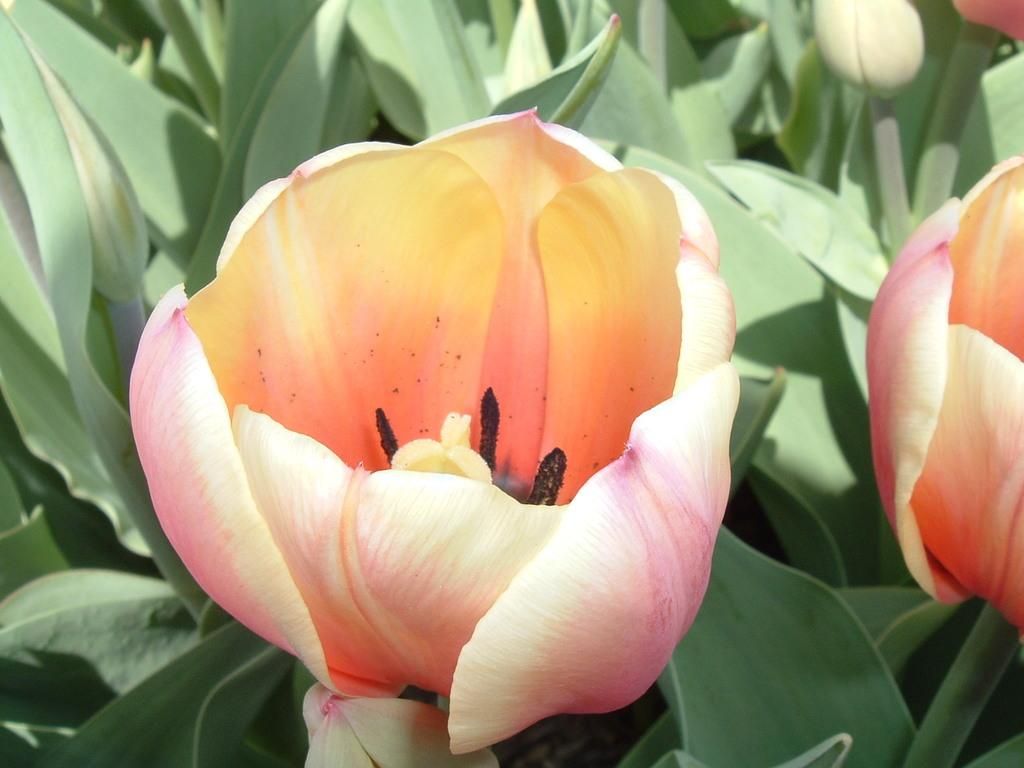What type of plant life is present in the image? There are flowers and buds in the image. Can you describe the stage of growth for the plants in the image? The plants in the image have buds, which suggests they are in the early stages of growth. What else can be seen in the background of the image? There are leaves visible in the background of the image. How many chairs are placed around the table in the image? There is no table or chairs present in the image; it features flowers and buds. 